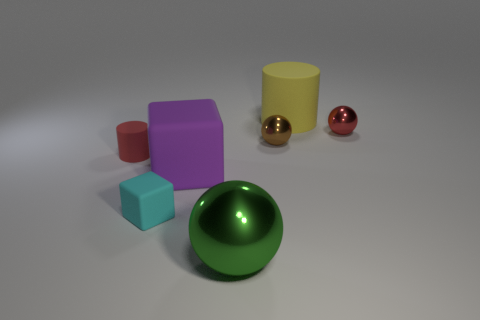Subtract all tiny spheres. How many spheres are left? 1 Subtract 1 balls. How many balls are left? 2 Add 1 green spheres. How many objects exist? 8 Subtract all cylinders. How many objects are left? 5 Subtract all gray balls. Subtract all green cubes. How many balls are left? 3 Add 7 tiny cyan rubber things. How many tiny cyan rubber things are left? 8 Add 7 big cubes. How many big cubes exist? 8 Subtract 0 yellow cubes. How many objects are left? 7 Subtract all big cyan metal objects. Subtract all red matte things. How many objects are left? 6 